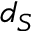Convert formula to latex. <formula><loc_0><loc_0><loc_500><loc_500>d _ { S }</formula> 